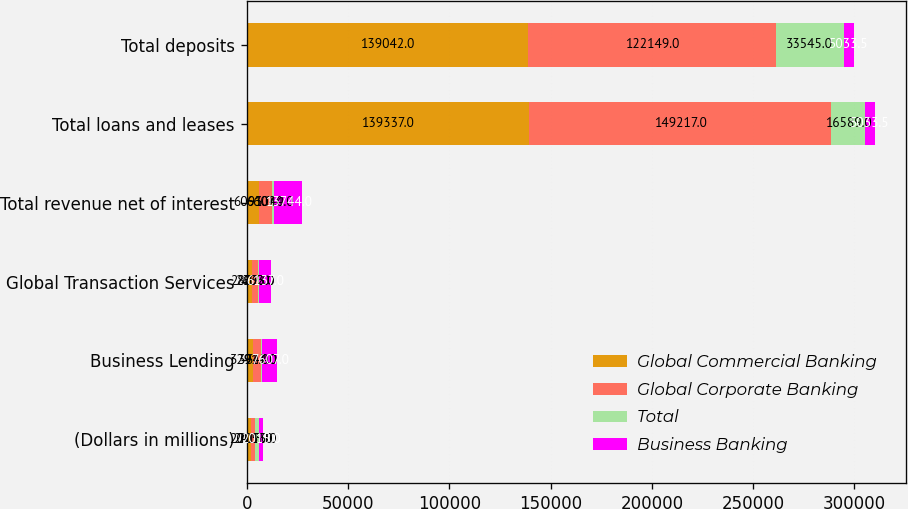Convert chart. <chart><loc_0><loc_0><loc_500><loc_500><stacked_bar_chart><ecel><fcel>(Dollars in millions)<fcel>Business Lending<fcel>Global Transaction Services<fcel>Total revenue net of interest<fcel>Total loans and leases<fcel>Total deposits<nl><fcel>Global Commercial Banking<fcel>2015<fcel>3291<fcel>2802<fcel>6093<fcel>139337<fcel>139042<nl><fcel>Global Corporate Banking<fcel>2015<fcel>3974<fcel>2633<fcel>6607<fcel>149217<fcel>122149<nl><fcel>Total<fcel>2015<fcel>342<fcel>702<fcel>1044<fcel>16589<fcel>33545<nl><fcel>Business Banking<fcel>2015<fcel>7607<fcel>6137<fcel>13744<fcel>5033.5<fcel>5033.5<nl></chart> 